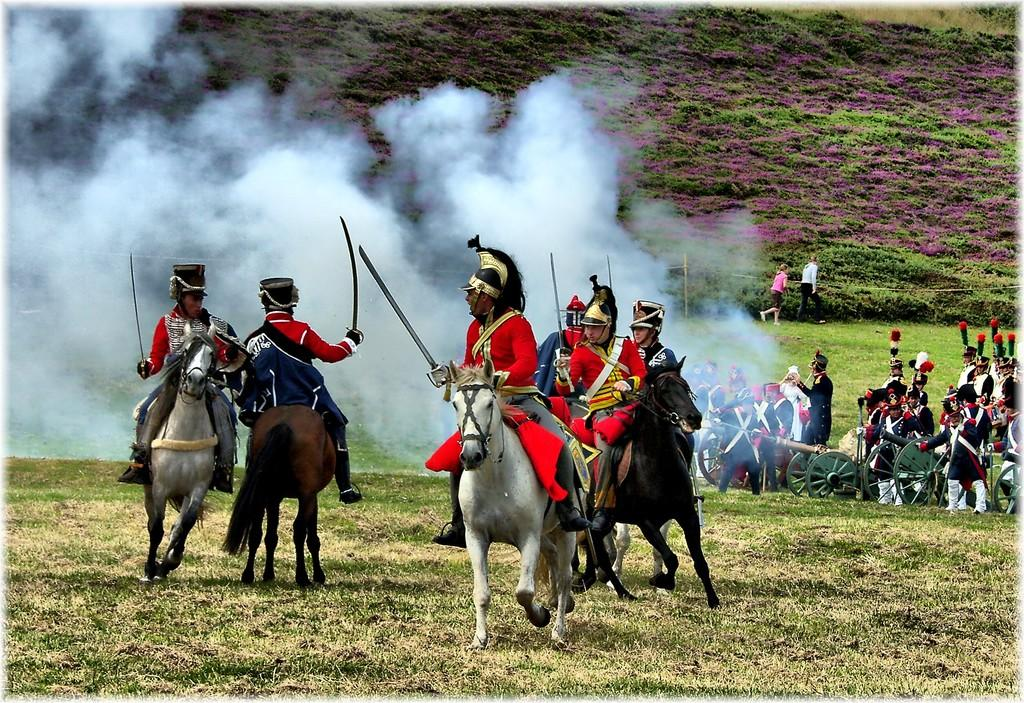How many people are in the image? There are people in the image, but the exact number is not specified. What are the people on horses doing? The people on horses are holding swords. What can be seen in the background of the image? In the background of the image, there are canons, grass, smoke, and other unspecified objects. What might be the purpose of the canons in the image? The presence of canons suggests that the scene could be related to a military or historical context. How deep is the hole that the people are digging in the image? There is no hole present in the image; the people are on horses holding swords. What type of lift is being used to transport the people in the image? There is no lift present in the image; the people are on horses. 